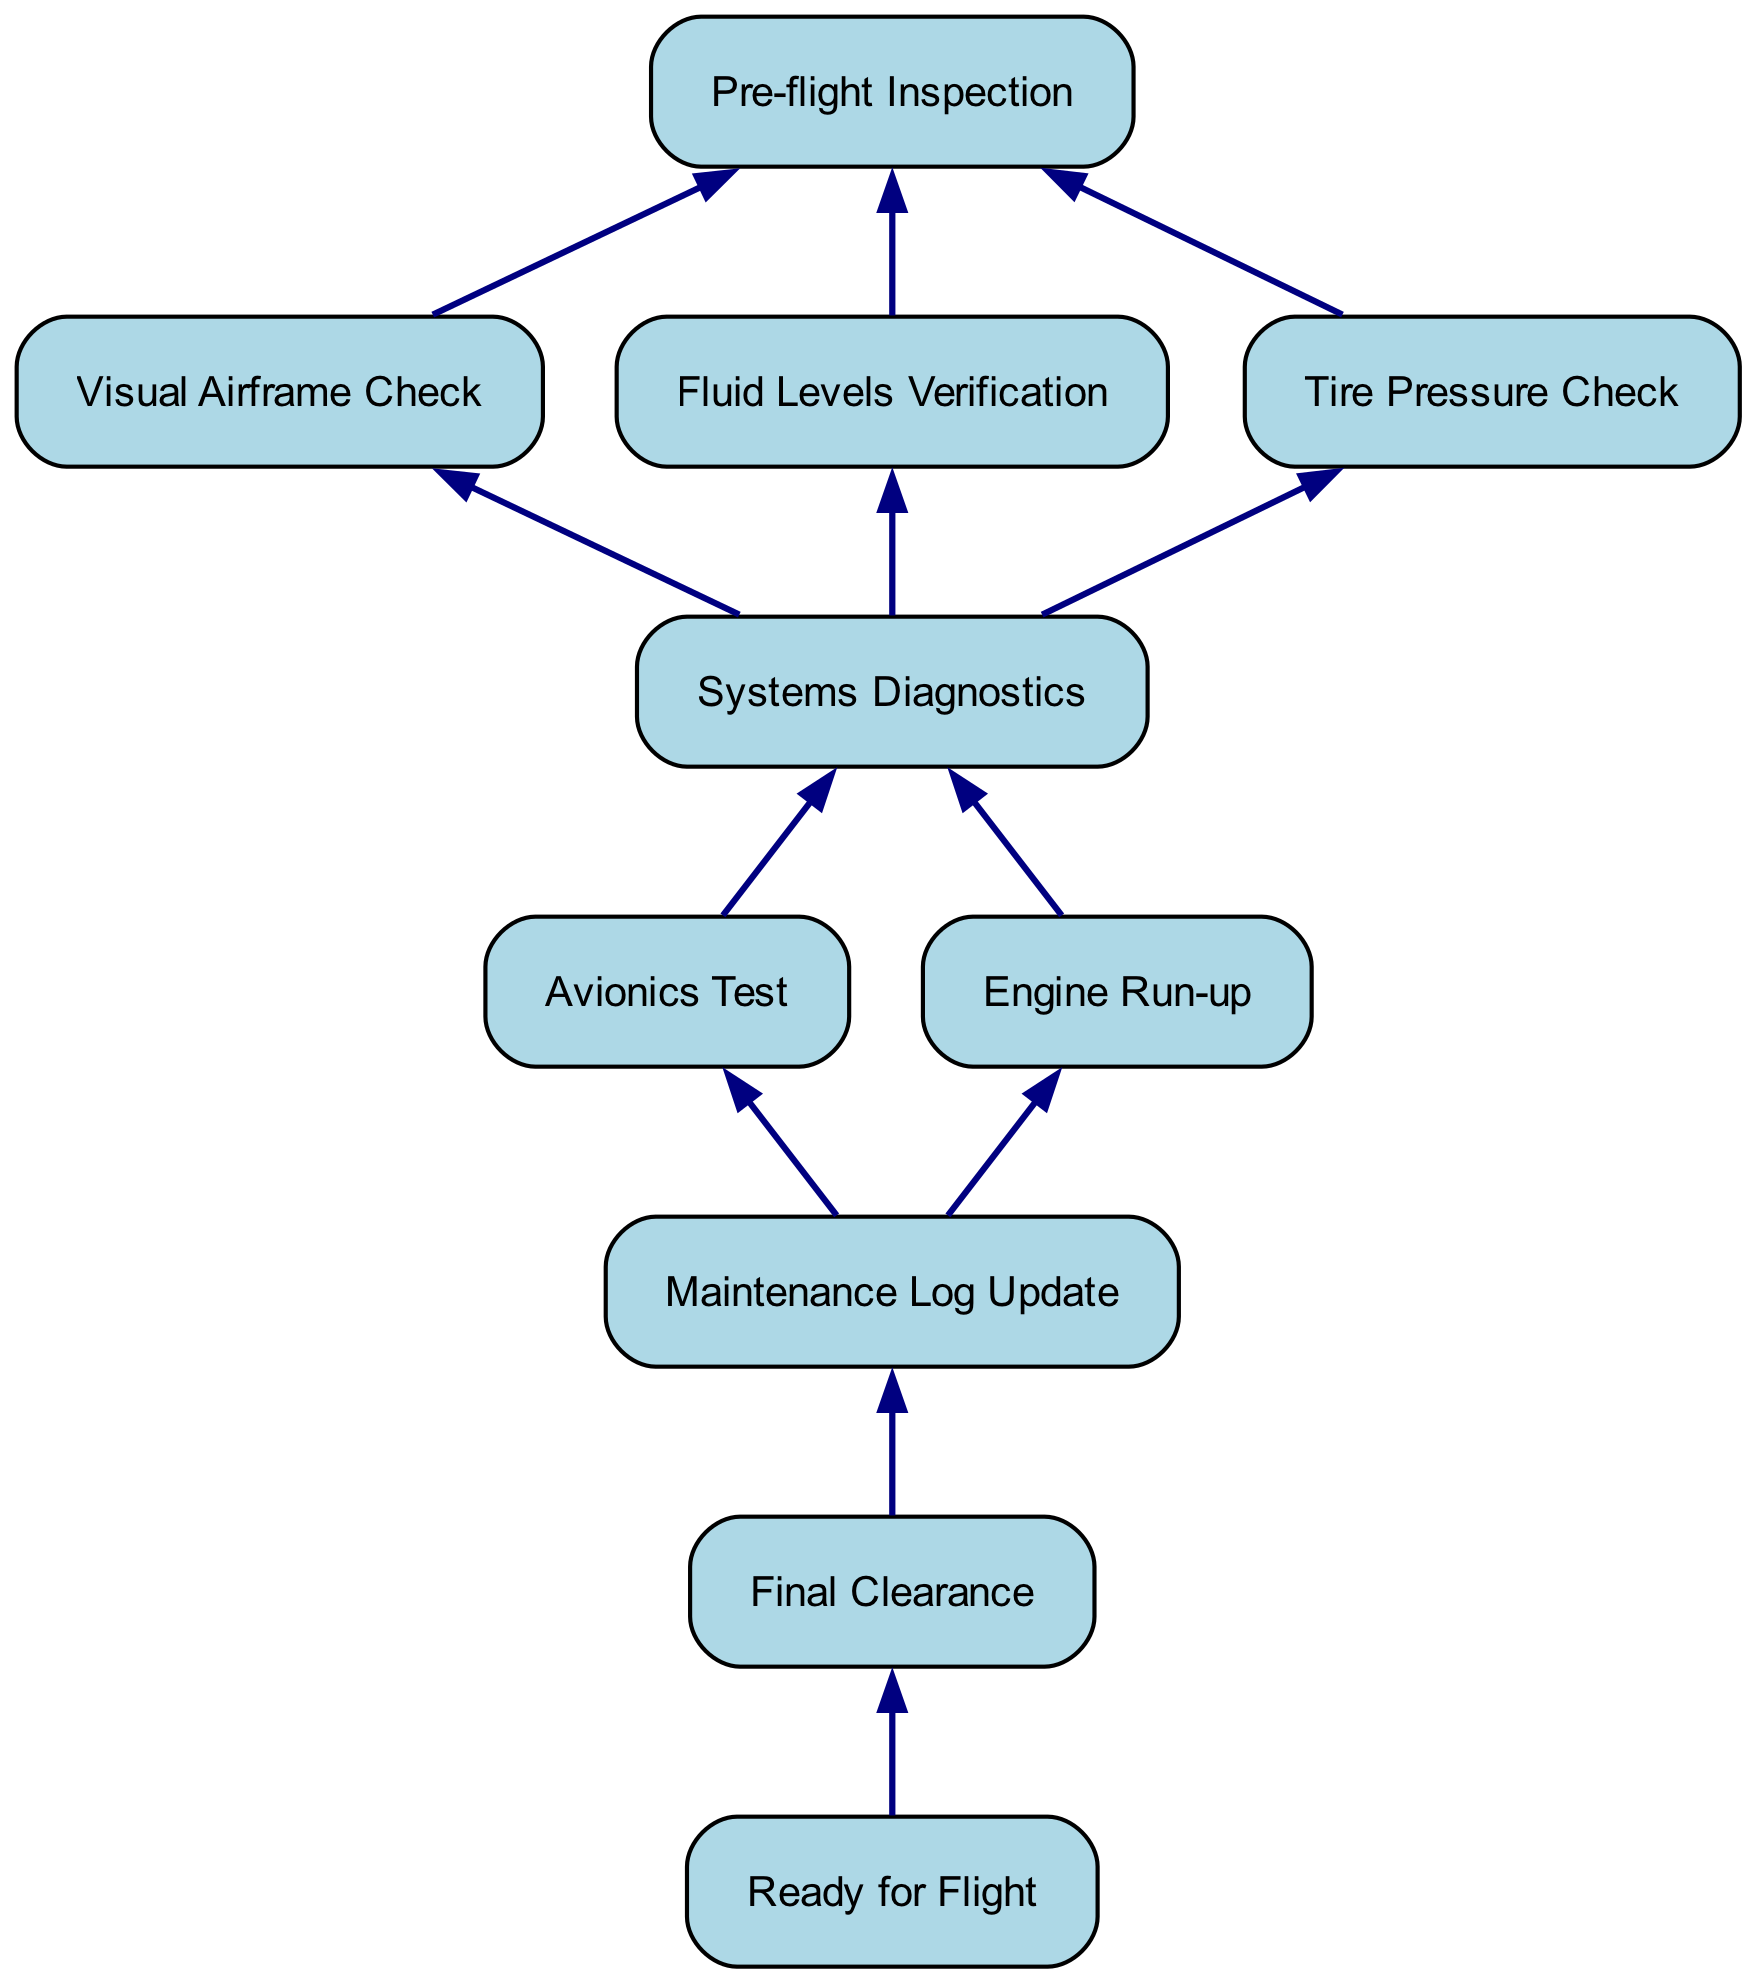What is the first step in the maintenance process? The first step in the diagram, as indicated at the top, is "Pre-flight Inspection." It is the starting point before any further actions are performed.
Answer: Pre-flight Inspection How many main checks are there under Pre-flight Inspection? There are three checks listed under "Pre-flight Inspection": "Visual Airframe Check," "Fluid Levels Verification," and "Tire Pressure Check," totaling three checks.
Answer: 3 What comes after Systems Diagnostics? After "Systems Diagnostics," the next step is "Maintenance Log Update," as indicated by the arrows in the diagram moving downward from "Systems Diagnostics."
Answer: Maintenance Log Update Which check is performed for verifying aircraft functionality? "Avionics Test" and "Engine Run-up" are both part of "Systems Diagnostics," which are critical for verifying the aircraft's functionality. Both checks are necessary for thorough diagnostics.
Answer: Avionics Test and Engine Run-up What final action is shown in the flow chart? The final action indicated in the flow chart is "Ready for Flight," which is the ultimate outcome after completing all the previous steps in the maintenance process.
Answer: Ready for Flight Which step follows the Tire Pressure Check? "Systems Diagnostics" follows "Tire Pressure Check," as it is the next step in the flow of the chart after all the pre-flight inspection checks are done.
Answer: Systems Diagnostics How many total steps are there in this maintenance process? The total steps in the maintenance process, from "Pre-flight Inspection" to "Ready for Flight," amount to ten distinctly labeled steps in the diagram.
Answer: 10 Which two processes are combined under Systems Diagnostics? "Avionics Test" and "Engine Run-up" are the two processes that are performed under "Systems Diagnostics," as evidenced by their branching from that node.
Answer: Avionics Test and Engine Run-up What is the relationship between Maintenance Log Update and Final Clearance? The relationship is that "Maintenance Log Update" directly leads to "Final Clearance," meaning that after the log is updated, the next step is to obtain final clearance for flight.
Answer: Final Clearance 